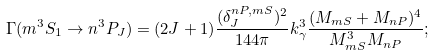Convert formula to latex. <formula><loc_0><loc_0><loc_500><loc_500>\Gamma ( m ^ { 3 } S _ { 1 } \to n ^ { 3 } P _ { J } ) = ( 2 J + 1 ) \frac { ( \delta _ { J } ^ { n P , m S } ) ^ { 2 } } { 1 4 4 \pi } k _ { \gamma } ^ { 3 } \frac { ( M _ { m S } + M _ { n P } ) ^ { 4 } } { M _ { m S } ^ { 3 } M _ { n P } } ;</formula> 